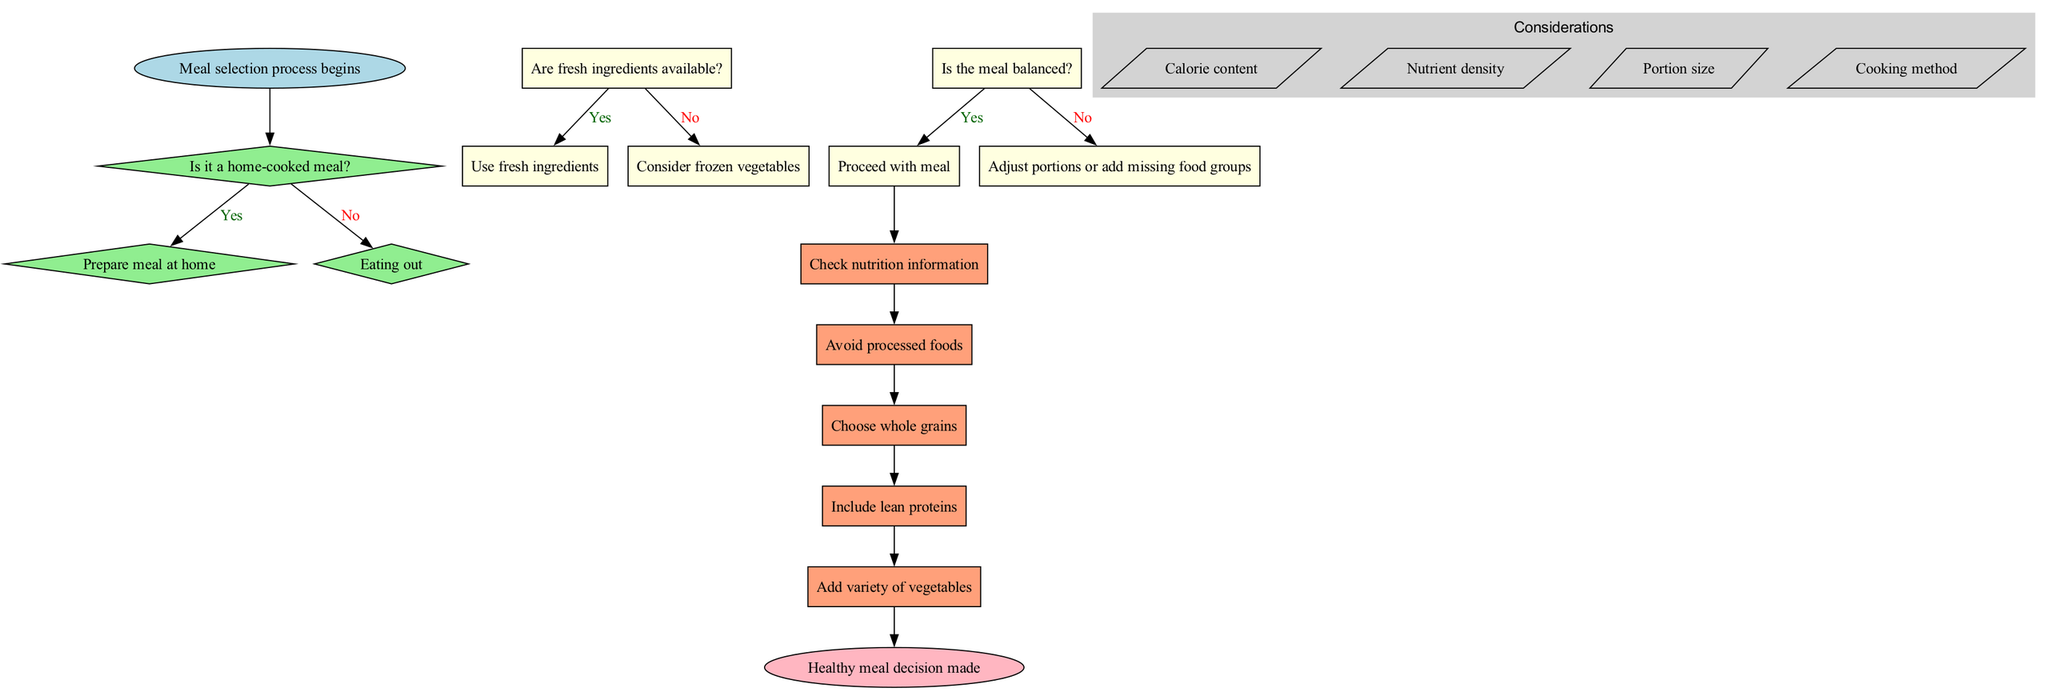What is the first decision point in the flowchart? The first decision point is labeled "Is it a home-cooked meal?" This is where the decision process begins, as it guides the selection route based on whether the meal is prepared at home or eaten out.
Answer: Is it a home-cooked meal? How many action nodes are present in the diagram? The diagram contains five action nodes. These action nodes are connected in sequence, and they represent the steps to follow after making the decision on the meal selection process.
Answer: 5 What happens if the meal is not balanced? If the meal is not balanced, the flowchart instructs to "Adjust portions or add missing food groups." This step emphasizes the importance of ensuring that the meal includes all necessary components for balance.
Answer: Adjust portions or add missing food groups What is a consideration mentioned in the flowchart? One of the considerations listed in the flowchart is "Calorie content." This indicates that when making meal choices, the calorie content of the food should be taken into account, which affects overall health.
Answer: Calorie content How does one proceed if there are no fresh ingredients available? If there are no fresh ingredients available, the flowchart suggests to "Consider frozen vegetables." This provides an alternative to ensure that some form of healthy ingredient can still be included in the meal selection.
Answer: Consider frozen vegetables What is the final outcome of the decision-making process in the flowchart? The final outcome of the decision-making process is "Healthy meal decision made." This signifies the successful conclusion of the meal selection based on the preceding steps and analysis of various factors.
Answer: Healthy meal decision made If the meal is home-cooked and balanced, what is the next step? If the meal is both home-cooked and balanced, the flowchart directs to "Proceed with meal." This indicates that both conditions had favorable outcomes leading to the final action of following through with the chosen meal.
Answer: Proceed with meal What is the shape of the nodes used for actions in the diagram? The nodes for actions in the diagram are shaped like rectangles. This specific shape identifies them as action steps in the flowchart, differentiating them from decision nodes.
Answer: Rectangle 